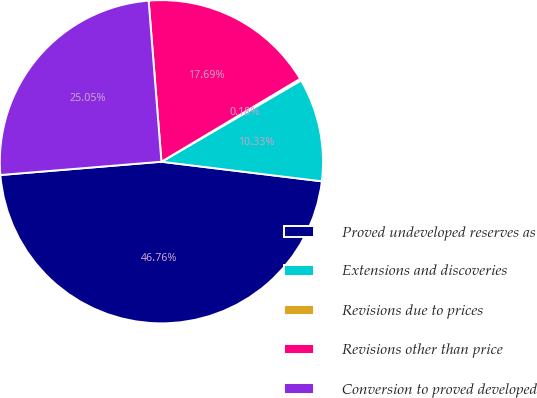Convert chart. <chart><loc_0><loc_0><loc_500><loc_500><pie_chart><fcel>Proved undeveloped reserves as<fcel>Extensions and discoveries<fcel>Revisions due to prices<fcel>Revisions other than price<fcel>Conversion to proved developed<nl><fcel>46.76%<fcel>10.33%<fcel>0.18%<fcel>17.69%<fcel>25.05%<nl></chart> 